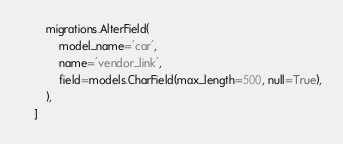Convert code to text. <code><loc_0><loc_0><loc_500><loc_500><_Python_>        migrations.AlterField(
            model_name='car',
            name='vendor_link',
            field=models.CharField(max_length=500, null=True),
        ),
    ]
</code> 